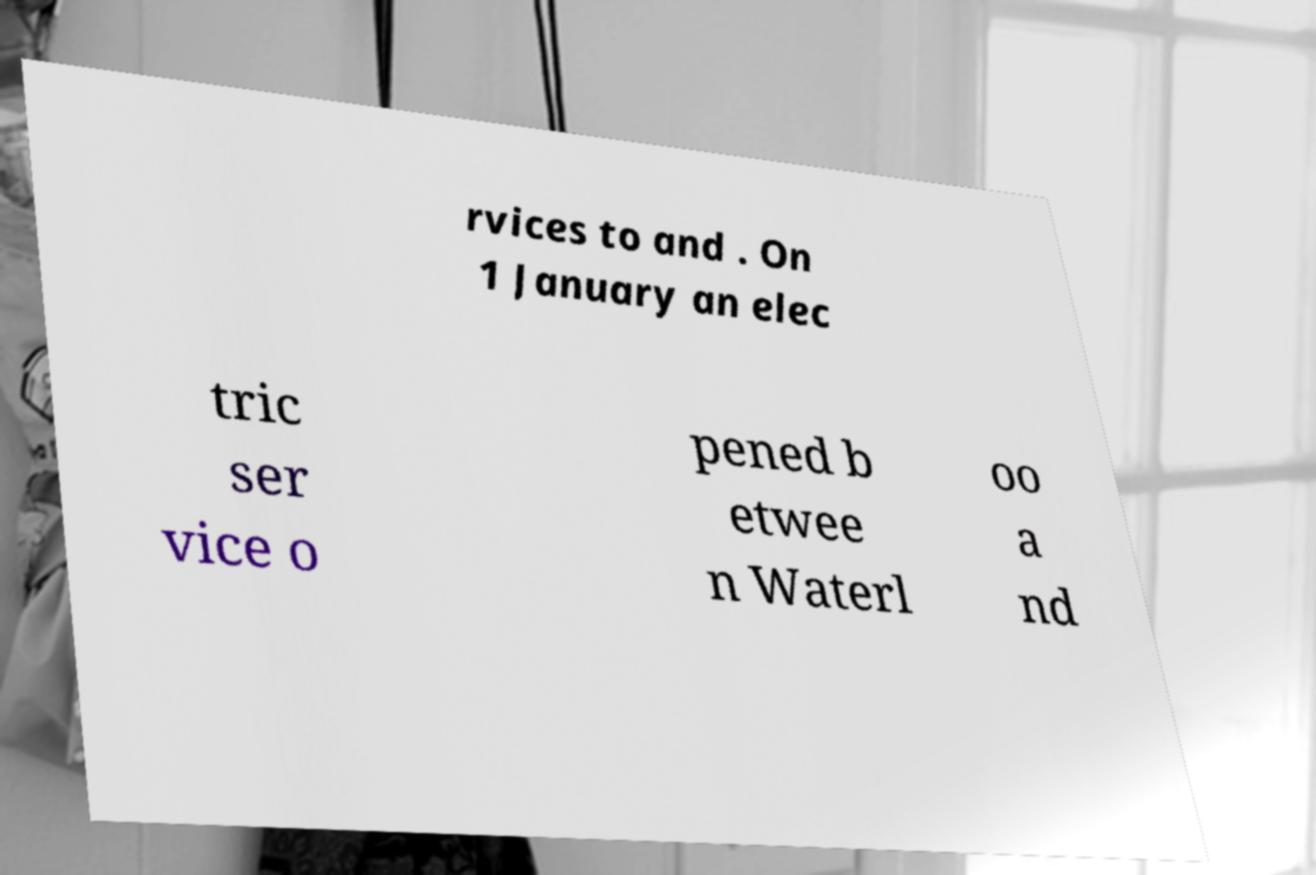What messages or text are displayed in this image? I need them in a readable, typed format. rvices to and . On 1 January an elec tric ser vice o pened b etwee n Waterl oo a nd 